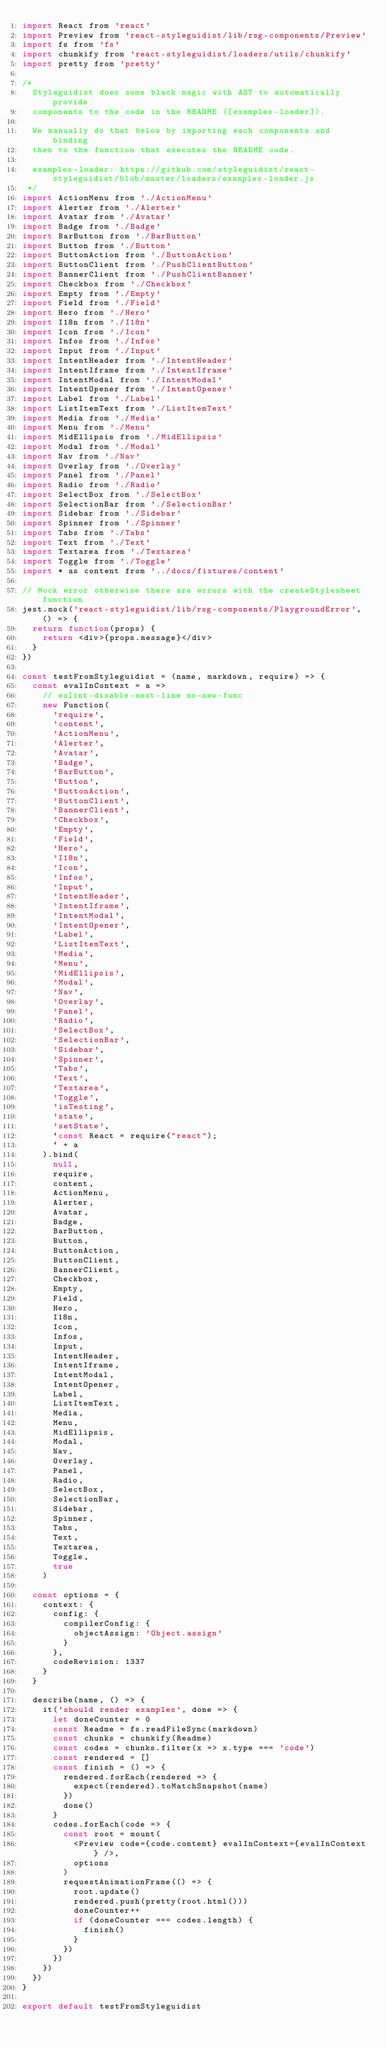<code> <loc_0><loc_0><loc_500><loc_500><_JavaScript_>import React from 'react'
import Preview from 'react-styleguidist/lib/rsg-components/Preview'
import fs from 'fs'
import chunkify from 'react-styleguidist/loaders/utils/chunkify'
import pretty from 'pretty'

/*
  Styleguidist does some black magic with AST to automatically provide
  components to the code in the README ([examples-loader]).

  We manually do that below by importing each components and binding
  them to the function that executes the README code.

  examples-loader: https://github.com/styleguidist/react-styleguidist/blob/master/loaders/examples-loader.js
 */
import ActionMenu from './ActionMenu'
import Alerter from './Alerter'
import Avatar from './Avatar'
import Badge from './Badge'
import BarButton from './BarButton'
import Button from './Button'
import ButtonAction from './ButtonAction'
import ButtonClient from './PushClientButton'
import BannerClient from './PushClientBanner'
import Checkbox from './Checkbox'
import Empty from './Empty'
import Field from './Field'
import Hero from './Hero'
import I18n from './I18n'
import Icon from './Icon'
import Infos from './Infos'
import Input from './Input'
import IntentHeader from './IntentHeader'
import IntentIframe from './IntentIframe'
import IntentModal from './IntentModal'
import IntentOpener from './IntentOpener'
import Label from './Label'
import ListItemText from './ListItemText'
import Media from './Media'
import Menu from './Menu'
import MidEllipsis from './MidEllipsis'
import Modal from './Modal'
import Nav from './Nav'
import Overlay from './Overlay'
import Panel from './Panel'
import Radio from './Radio'
import SelectBox from './SelectBox'
import SelectionBar from './SelectionBar'
import Sidebar from './Sidebar'
import Spinner from './Spinner'
import Tabs from './Tabs'
import Text from './Text'
import Textarea from './Textarea'
import Toggle from './Toggle'
import * as content from '../docs/fixtures/content'

// Mock error otherwise there are errors with the createStylesheet function
jest.mock('react-styleguidist/lib/rsg-components/PlaygroundError', () => {
  return function(props) {
    return <div>{props.message}</div>
  }
})

const testFromStyleguidist = (name, markdown, require) => {
  const evalInContext = a =>
    // eslint-disable-next-line no-new-func
    new Function(
      'require',
      'content',
      'ActionMenu',
      'Alerter',
      'Avatar',
      'Badge',
      'BarButton',
      'Button',
      'ButtonAction',
      'ButtonClient',
      'BannerClient',
      'Checkbox',
      'Empty',
      'Field',
      'Hero',
      'I18n',
      'Icon',
      'Infos',
      'Input',
      'IntentHeader',
      'IntentIframe',
      'IntentModal',
      'IntentOpener',
      'Label',
      'ListItemText',
      'Media',
      'Menu',
      'MidEllipsis',
      'Modal',
      'Nav',
      'Overlay',
      'Panel',
      'Radio',
      'SelectBox',
      'SelectionBar',
      'Sidebar',
      'Spinner',
      'Tabs',
      'Text',
      'Textarea',
      'Toggle',
      'isTesting',
      'state',
      'setState',
      `const React = require("react");
      ` + a
    ).bind(
      null,
      require,
      content,
      ActionMenu,
      Alerter,
      Avatar,
      Badge,
      BarButton,
      Button,
      ButtonAction,
      ButtonClient,
      BannerClient,
      Checkbox,
      Empty,
      Field,
      Hero,
      I18n,
      Icon,
      Infos,
      Input,
      IntentHeader,
      IntentIframe,
      IntentModal,
      IntentOpener,
      Label,
      ListItemText,
      Media,
      Menu,
      MidEllipsis,
      Modal,
      Nav,
      Overlay,
      Panel,
      Radio,
      SelectBox,
      SelectionBar,
      Sidebar,
      Spinner,
      Tabs,
      Text,
      Textarea,
      Toggle,
      true
    )

  const options = {
    context: {
      config: {
        compilerConfig: {
          objectAssign: 'Object.assign'
        }
      },
      codeRevision: 1337
    }
  }

  describe(name, () => {
    it('should render examples', done => {
      let doneCounter = 0
      const Readme = fs.readFileSync(markdown)
      const chunks = chunkify(Readme)
      const codes = chunks.filter(x => x.type === 'code')
      const rendered = []
      const finish = () => {
        rendered.forEach(rendered => {
          expect(rendered).toMatchSnapshot(name)
        })
        done()
      }
      codes.forEach(code => {
        const root = mount(
          <Preview code={code.content} evalInContext={evalInContext} />,
          options
        )
        requestAnimationFrame(() => {
          root.update()
          rendered.push(pretty(root.html()))
          doneCounter++
          if (doneCounter === codes.length) {
            finish()
          }
        })
      })
    })
  })
}

export default testFromStyleguidist
</code> 